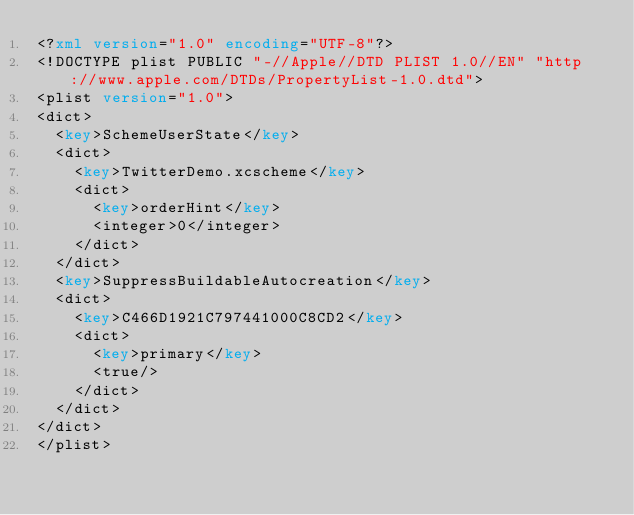<code> <loc_0><loc_0><loc_500><loc_500><_XML_><?xml version="1.0" encoding="UTF-8"?>
<!DOCTYPE plist PUBLIC "-//Apple//DTD PLIST 1.0//EN" "http://www.apple.com/DTDs/PropertyList-1.0.dtd">
<plist version="1.0">
<dict>
	<key>SchemeUserState</key>
	<dict>
		<key>TwitterDemo.xcscheme</key>
		<dict>
			<key>orderHint</key>
			<integer>0</integer>
		</dict>
	</dict>
	<key>SuppressBuildableAutocreation</key>
	<dict>
		<key>C466D1921C797441000C8CD2</key>
		<dict>
			<key>primary</key>
			<true/>
		</dict>
	</dict>
</dict>
</plist>
</code> 